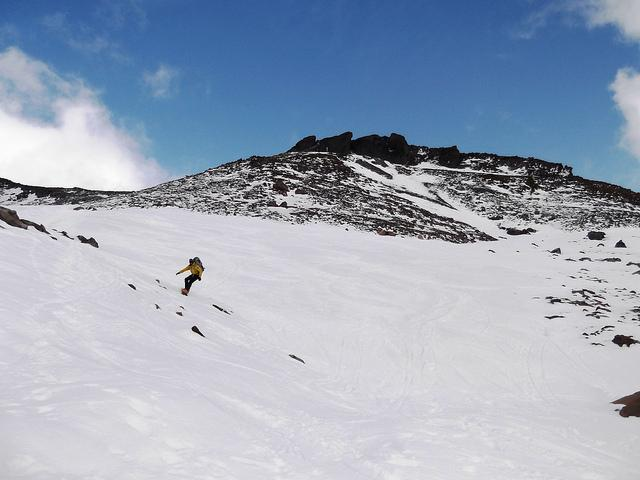What sort of weather happens here frequently?

Choices:
A) flood
B) rain
C) sleet
D) wind wind 